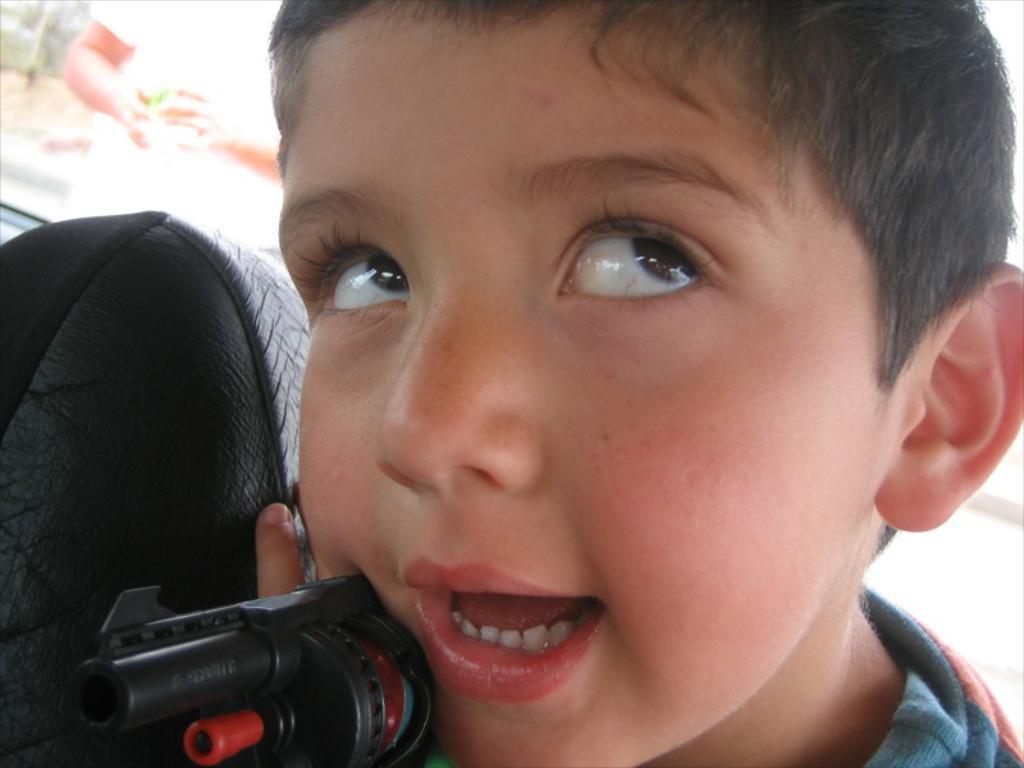In one or two sentences, can you explain what this image depicts? This picture looks like a boy seated in the vehicle and he is holding a toy gun in his hand and from the vehicle glass I can see a human and few trees. 